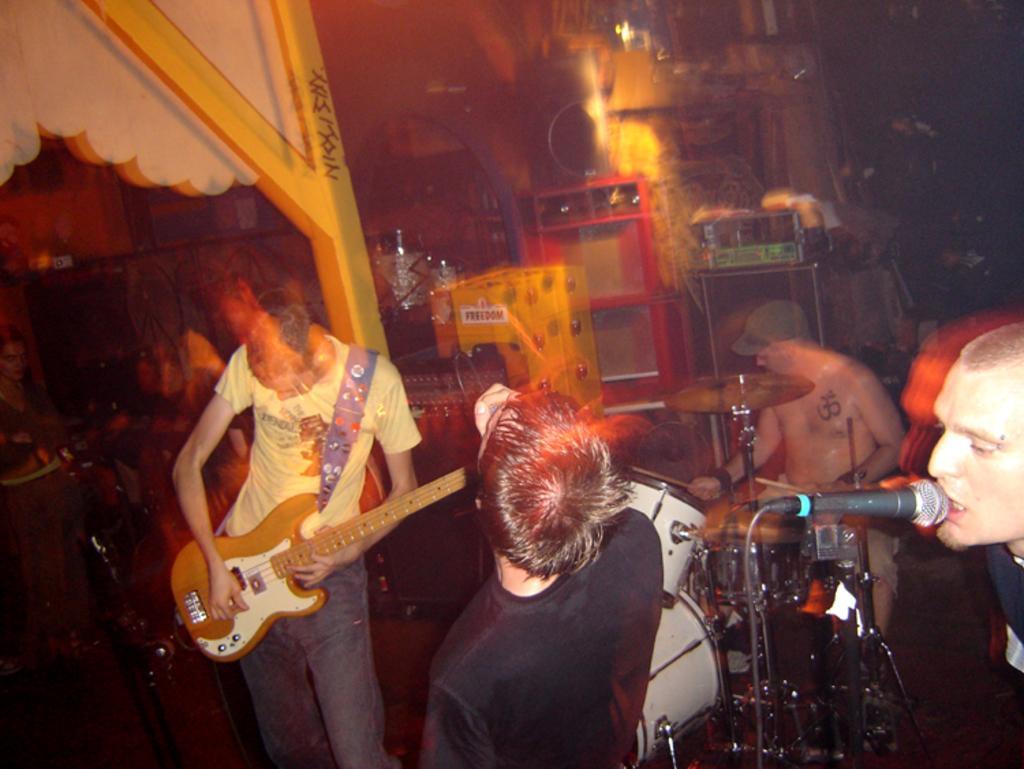Can you describe this image briefly? There are group of people playing music and the person in the right is singing in front of a mic. 